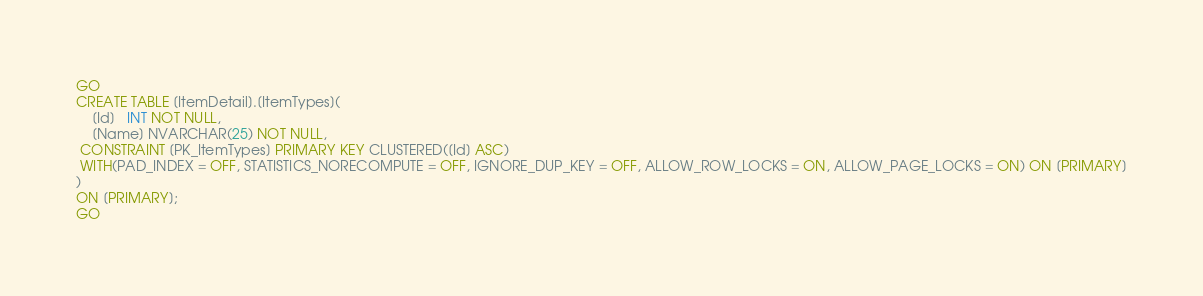Convert code to text. <code><loc_0><loc_0><loc_500><loc_500><_SQL_>GO
CREATE TABLE [ItemDetail].[ItemTypes](
	[Id]   INT NOT NULL, 
	[Name] NVARCHAR(25) NOT NULL, 
 CONSTRAINT [PK_ItemTypes] PRIMARY KEY CLUSTERED([Id] ASC)
 WITH(PAD_INDEX = OFF, STATISTICS_NORECOMPUTE = OFF, IGNORE_DUP_KEY = OFF, ALLOW_ROW_LOCKS = ON, ALLOW_PAGE_LOCKS = ON) ON [PRIMARY]
)
ON [PRIMARY];
GO</code> 